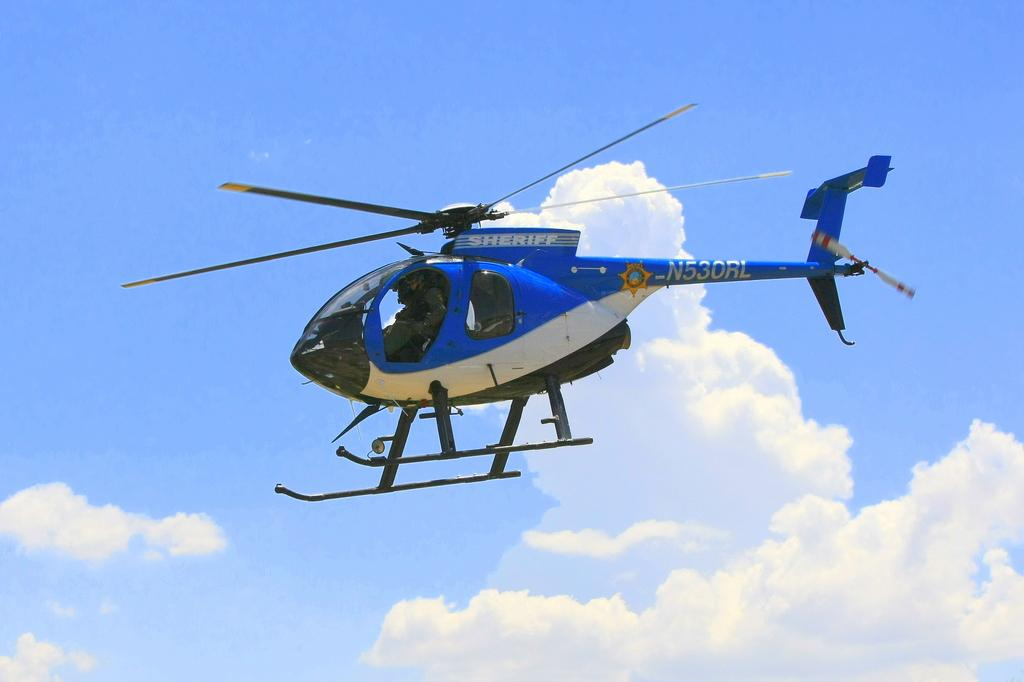What is the main subject of the picture? The main subject of the picture is a helicopter. What is the helicopter doing in the image? The helicopter is flying in the image. What can be seen in the background of the picture? The sky is visible in the background of the image. How many sisters are sitting on the sink in the image? There are no sisters or sink present in the image; it features a helicopter flying in the sky. 